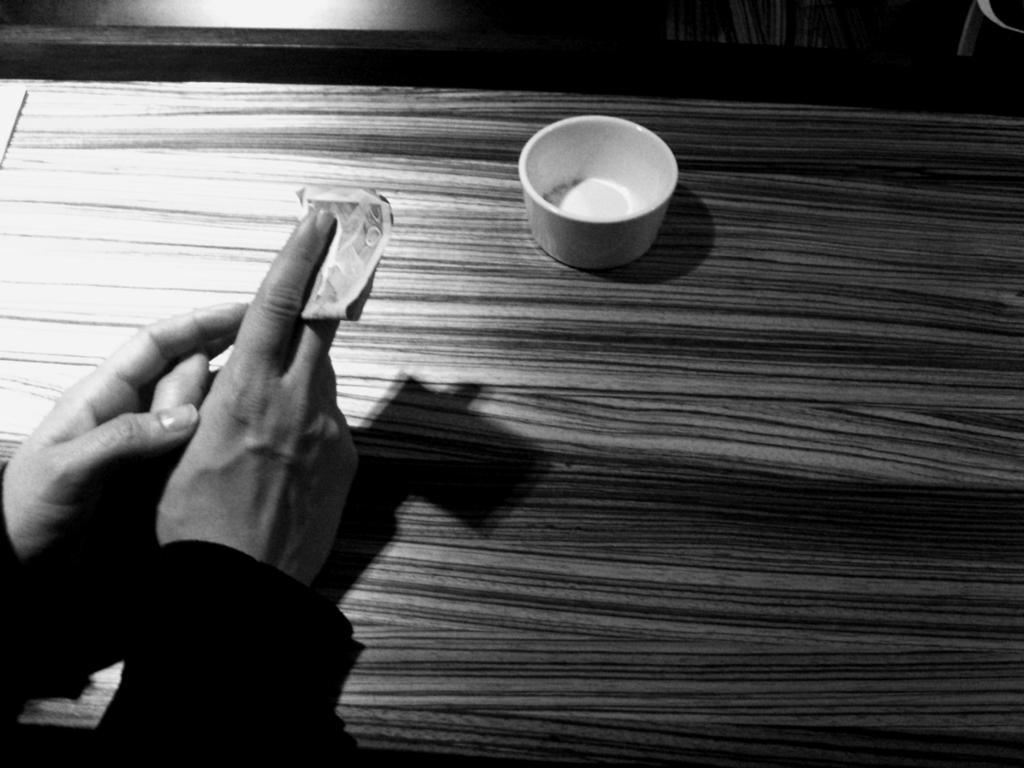Can you describe this image briefly? In this picture we can see a cup on the table. We can see a partial part of human hands holding a paper. This is a black and white picture. 